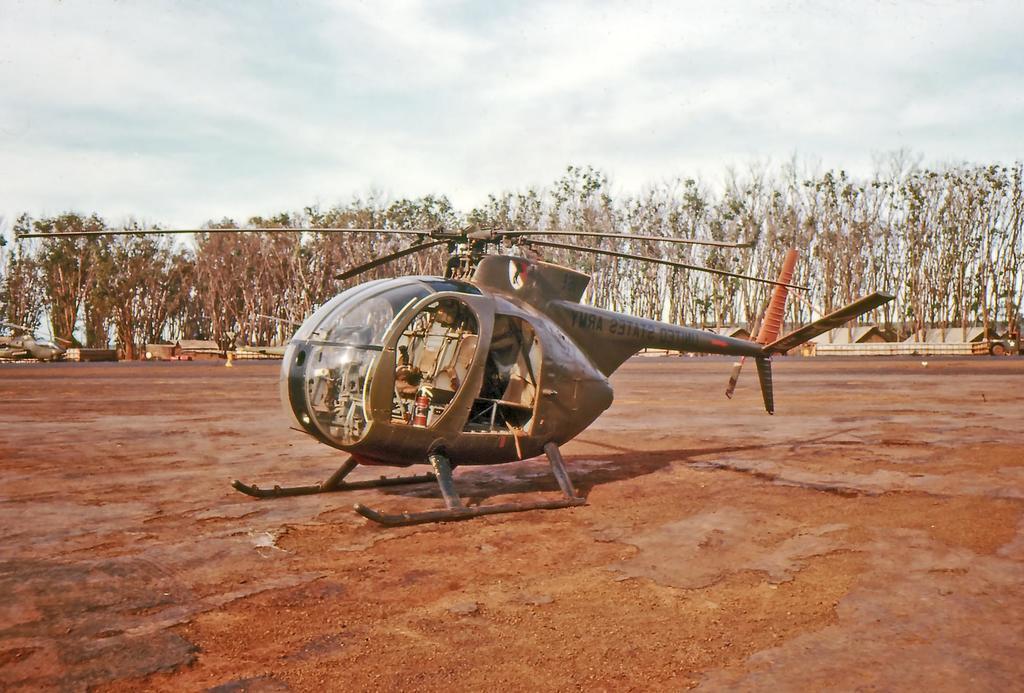Can you describe this image briefly? In this picture I can see a plan on the ground, behind there are some houses and trees. 